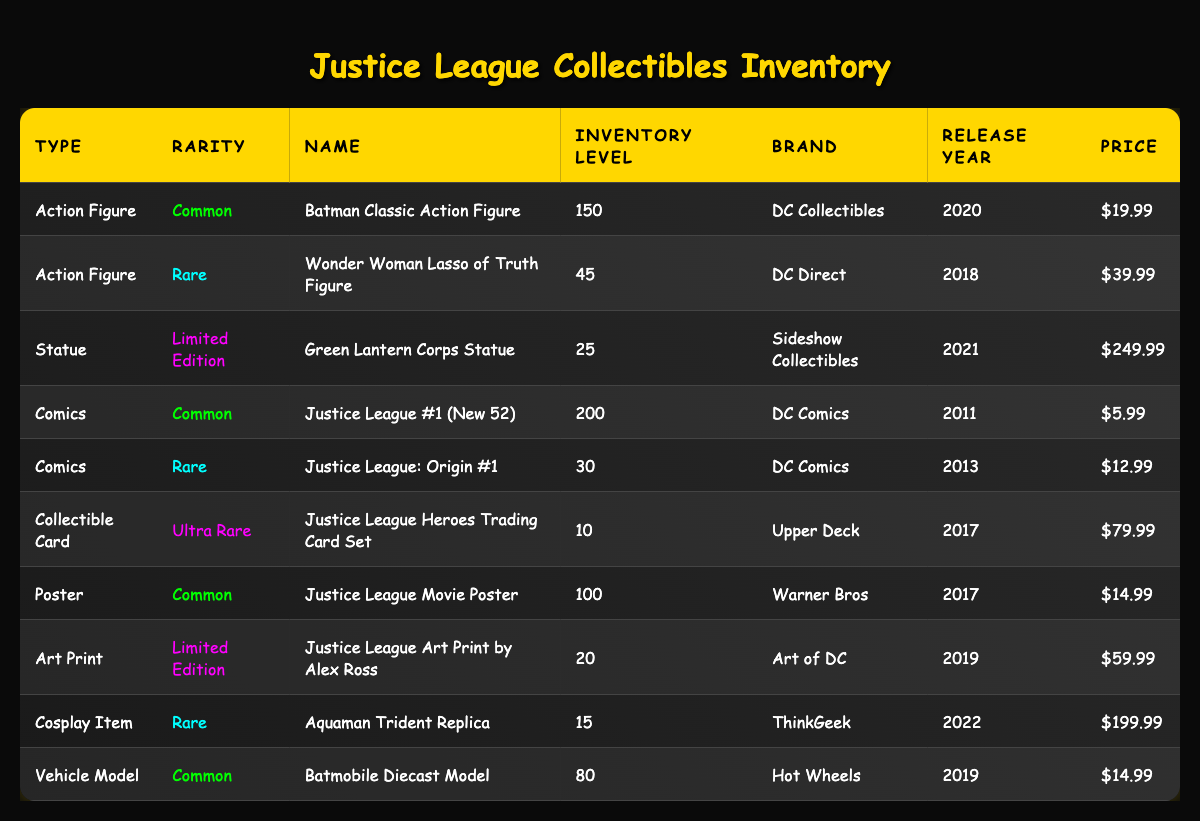What is the highest inventory level among the collectibles? The highest inventory level can be found by scanning the "Inventory Level" column. The values listed include 150, 45, 25, 200, 30, 10, 100, 20, 15, and 80. The largest number is 200, corresponding to "Justice League #1 (New 52)."
Answer: 200 How many rare collectibles are there in total? To find the total number of rare collectibles, count the entries labeled as "Rare" in the "Rarity" column. There are 3 collectibles: the "Wonder Woman Lasso of Truth Figure," "Justice League: Origin #1," and "Aquaman Trident Replica." The total count for those is 45 + 30 + 15 = 90.
Answer: 90 Which collectible has the highest price? The prices listed are $19.99, $39.99, $249.99, $5.99, $12.99, $79.99, $14.99, $59.99, $199.99, and $14.99. Scanning through, the highest price is $249.99 for the "Green Lantern Corps Statue."
Answer: $249.99 Is there a common collectible type with more than 100 units in stock? The "Type" column shows that "Comics," "Action Figures," "Posters," and "Vehicle Models" are common. Checking their inventory levels, "Justice League #1 (New 52)" has 200 and "Batman Classic Action Figure" has 150, both over 100. Therefore, the answer is yes.
Answer: Yes What is the total inventory level of action figures? The inventory levels for action figures are 150 (Batman Classic) and 45 (Wonder Woman). Adding these values (150 + 45) gives a total of 195 for action figures.
Answer: 195 How many collectibles are from the year 2019? Check the "Release Year" column for the year 2019. The collectibles released that year are "Batmobile Diecast Model" and "Justice League Art Print by Alex Ross." There are 2 items from 2019.
Answer: 2 What types of collectibles have limited edition items? Looking at the "Type" and "Rarity" columns, the items that are limited edition are the "Green Lantern Corps Statue" and "Justice League Art Print by Alex Ross." The types for these are "Statue" and "Art Print" respectively.
Answer: Statue, Art Print What is the average price of all collectibles? The prices listed are $19.99, $39.99, $249.99, $5.99, $12.99, $79.99, $14.99, $59.99, $199.99, and $14.99. Adding them gives a total of $240.90 for 10 items. Calculating the average (240.90/10) results in $24.09.
Answer: $24.09 How many collectibles are available under the "Ultra Rare" category? Only one item is classified as ultra-rare: the "Justice League Heroes Trading Card Set," which has an inventory level of 10. Thus, there is only 1 ultra-rare collectible.
Answer: 1 What is the difference in inventory levels between the highest and lowest valued collectible? The highest inventory level is 200 (Justice League #1) and the lowest is 10 (Justice League Heroes Trading Card Set). Calculating the difference gives 200 - 10 = 190.
Answer: 190 